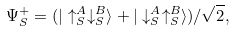<formula> <loc_0><loc_0><loc_500><loc_500>\Psi ^ { + } _ { S } = ( | \uparrow _ { S } ^ { A } \downarrow _ { S } ^ { B } \rangle + | \downarrow _ { S } ^ { A } \uparrow _ { S } ^ { B } \rangle ) / \sqrt { 2 } ,</formula> 